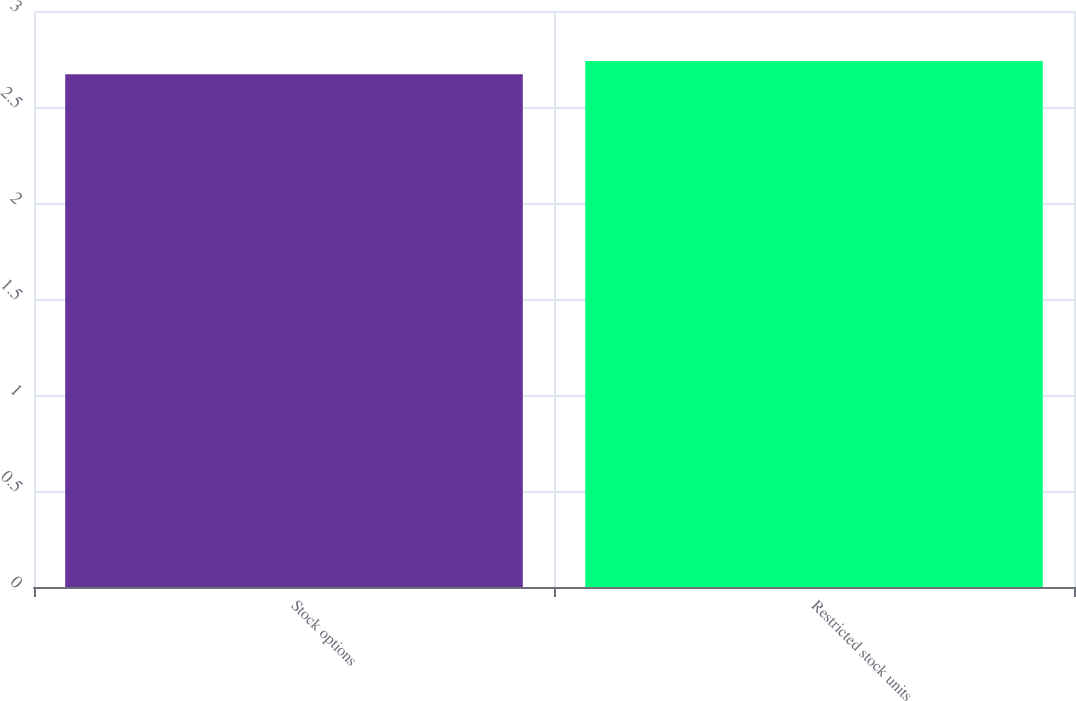<chart> <loc_0><loc_0><loc_500><loc_500><bar_chart><fcel>Stock options<fcel>Restricted stock units<nl><fcel>2.67<fcel>2.74<nl></chart> 